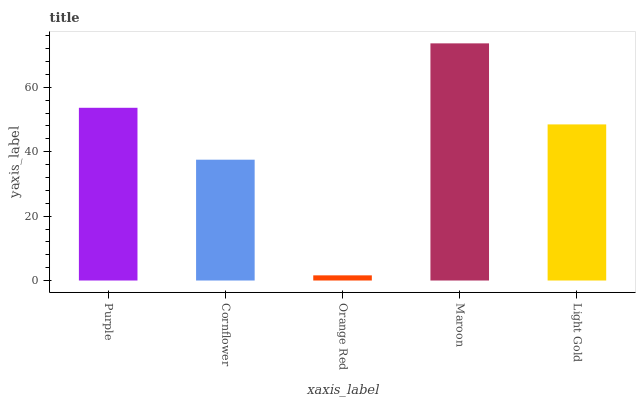Is Orange Red the minimum?
Answer yes or no. Yes. Is Maroon the maximum?
Answer yes or no. Yes. Is Cornflower the minimum?
Answer yes or no. No. Is Cornflower the maximum?
Answer yes or no. No. Is Purple greater than Cornflower?
Answer yes or no. Yes. Is Cornflower less than Purple?
Answer yes or no. Yes. Is Cornflower greater than Purple?
Answer yes or no. No. Is Purple less than Cornflower?
Answer yes or no. No. Is Light Gold the high median?
Answer yes or no. Yes. Is Light Gold the low median?
Answer yes or no. Yes. Is Maroon the high median?
Answer yes or no. No. Is Maroon the low median?
Answer yes or no. No. 